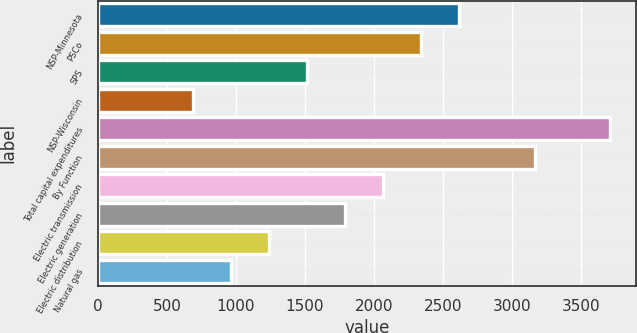<chart> <loc_0><loc_0><loc_500><loc_500><bar_chart><fcel>NSP-Minnesota<fcel>PSCo<fcel>SPS<fcel>NSP-Wisconsin<fcel>Total capital expenditures<fcel>By Function<fcel>Electric transmission<fcel>Electric generation<fcel>Electric distribution<fcel>Natural gas<nl><fcel>2615<fcel>2340<fcel>1515<fcel>690<fcel>3715<fcel>3165<fcel>2065<fcel>1790<fcel>1240<fcel>965<nl></chart> 